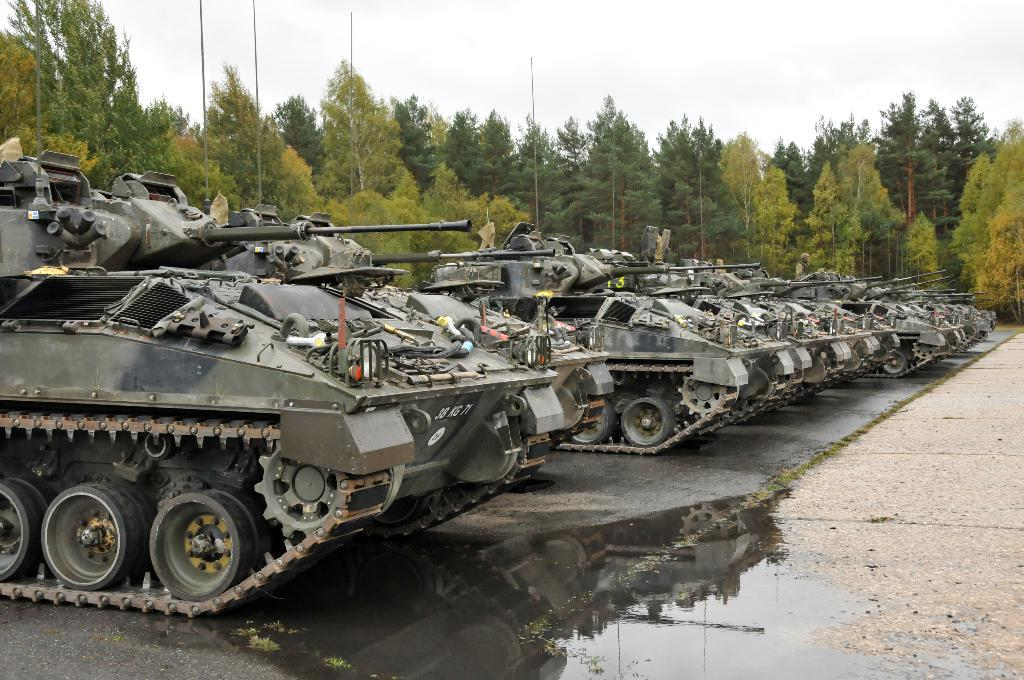What type of vehicles are parked in the image? There are tankers parked in the image. What is the condition of the water visible in the image? The water visible in the image is muddy. What can be seen in the background of the image? There are trees and the sky visible in the background of the image. What type of arm is visible in the image? There is no arm visible in the image. What season is depicted in the image? The provided facts do not indicate a specific season, so it cannot be determined from the image. 